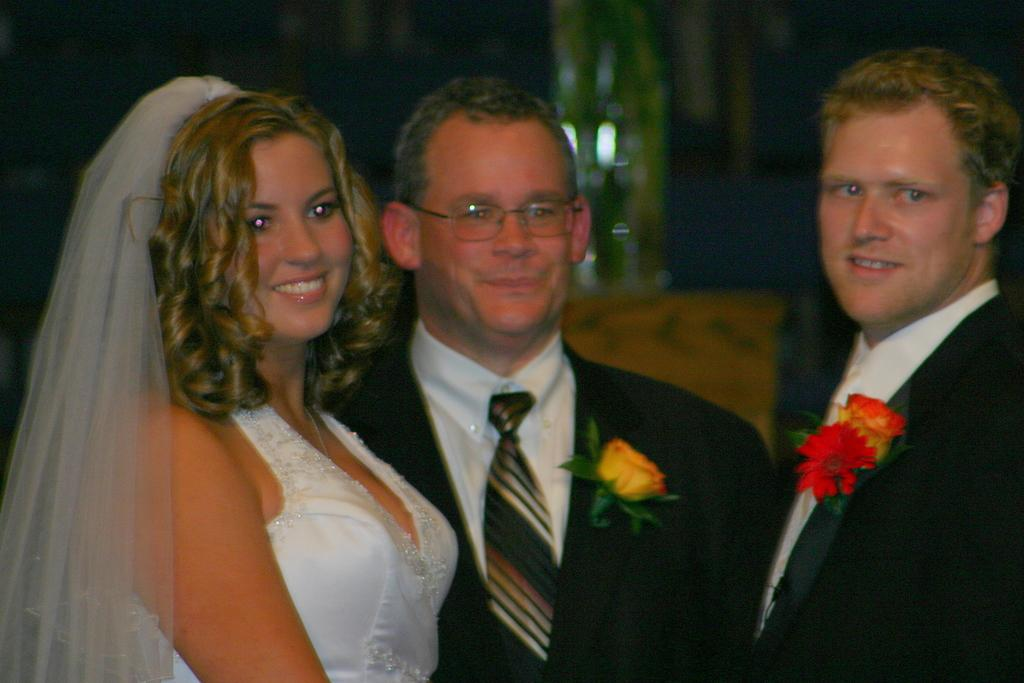How many men are in the foreground of the image? There are two men in the foreground of the image. What are the men wearing? The men are wearing suits with flowers on them. Can you describe the woman in the image? The woman is wearing a white dress. What is the color of the background in the image? The background of the image is dark. What type of pear is the woman holding in the image? There is no pear present in the image; the woman is wearing a white dress. Can you tell me where the needle is located in the image? There is no needle present in the image. 